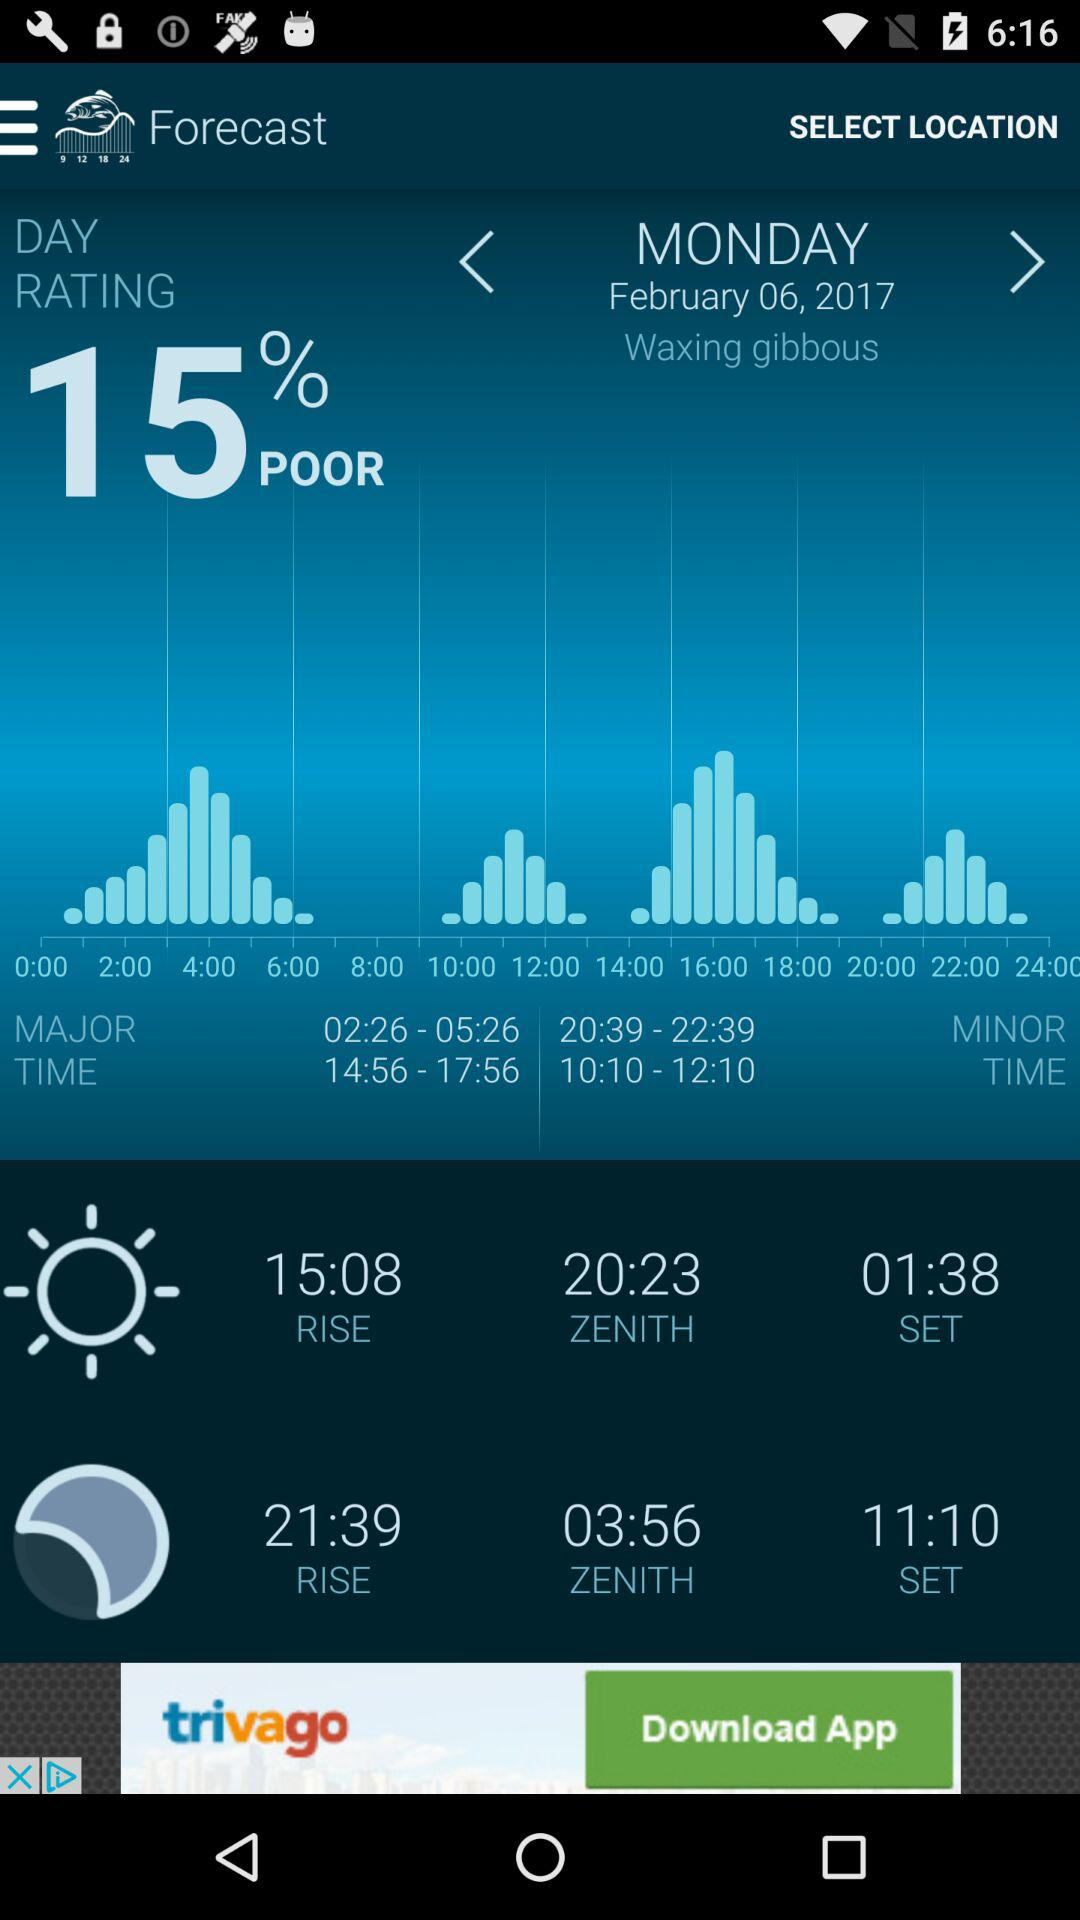What is the given date? The given date is Monday, February 6, 2017. 